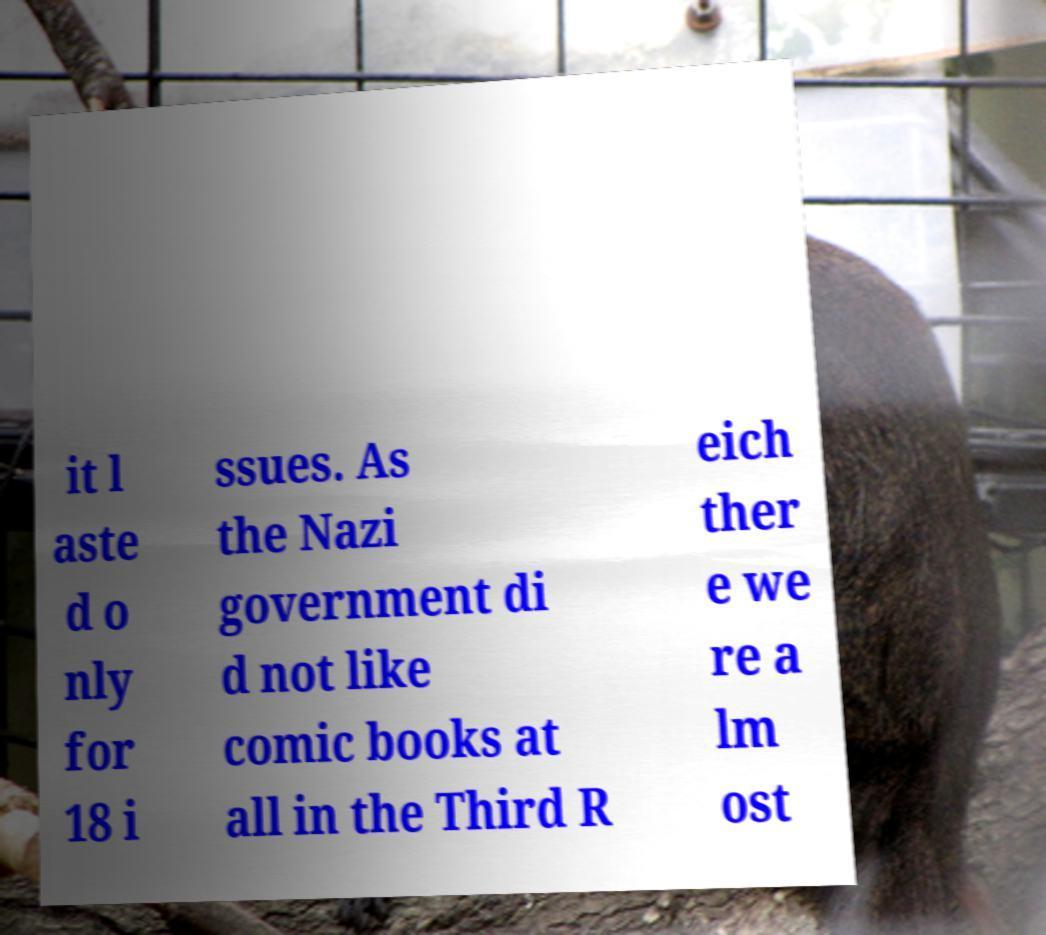Could you assist in decoding the text presented in this image and type it out clearly? it l aste d o nly for 18 i ssues. As the Nazi government di d not like comic books at all in the Third R eich ther e we re a lm ost 